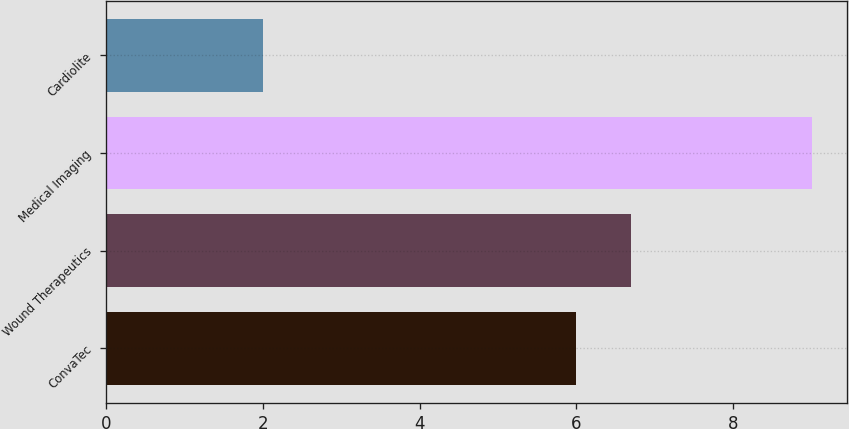Convert chart to OTSL. <chart><loc_0><loc_0><loc_500><loc_500><bar_chart><fcel>ConvaTec<fcel>Wound Therapeutics<fcel>Medical Imaging<fcel>Cardiolite<nl><fcel>6<fcel>6.7<fcel>9<fcel>2<nl></chart> 